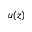<formula> <loc_0><loc_0><loc_500><loc_500>u ( z )</formula> 